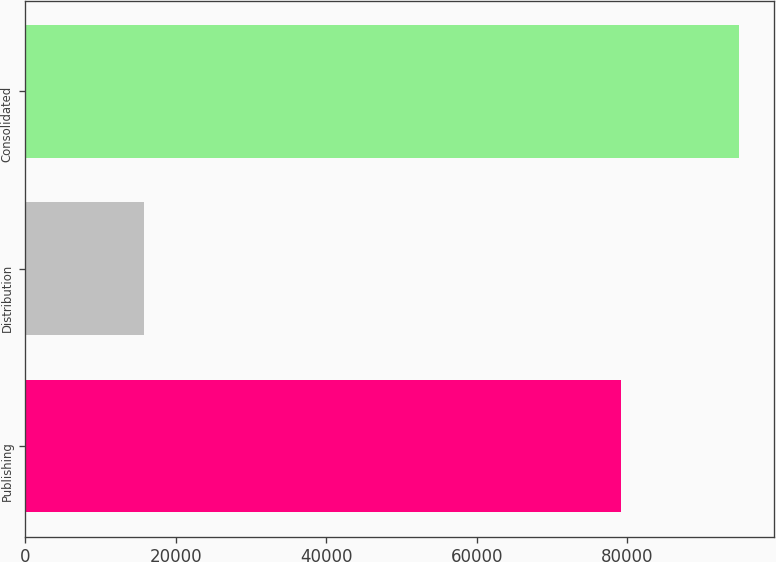<chart> <loc_0><loc_0><loc_500><loc_500><bar_chart><fcel>Publishing<fcel>Distribution<fcel>Consolidated<nl><fcel>79139<fcel>15708<fcel>94847<nl></chart> 